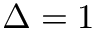<formula> <loc_0><loc_0><loc_500><loc_500>\Delta = 1</formula> 